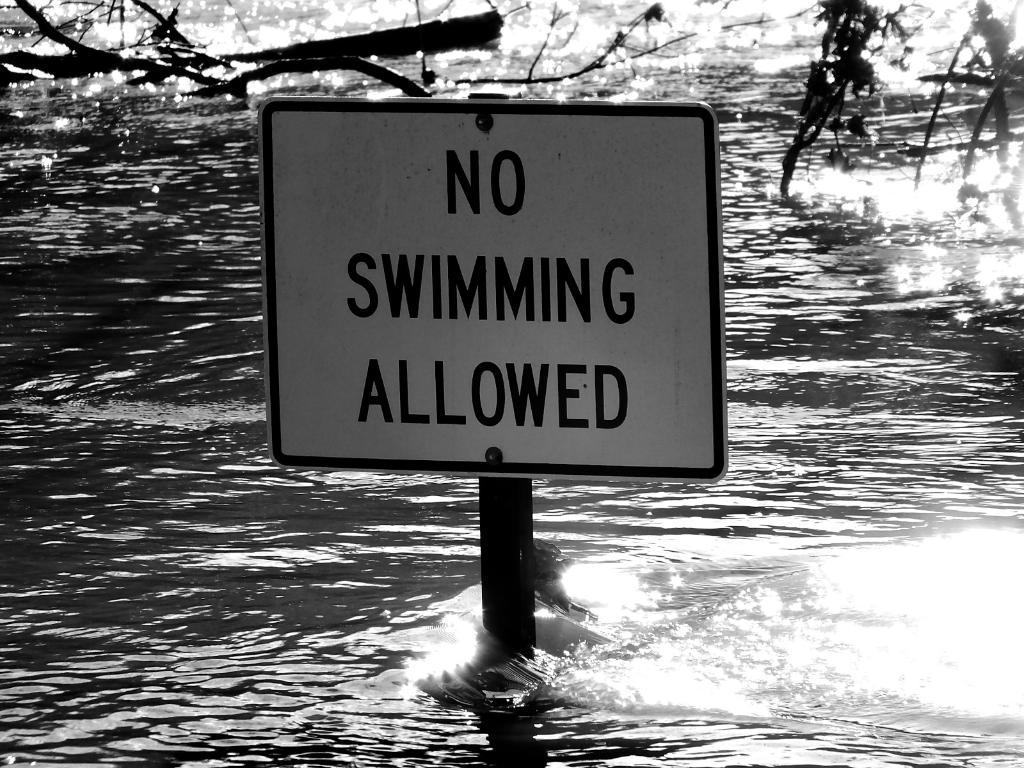What is the main object in the middle of the image? There is a board in the middle of the image. What can be seen in the distance behind the board? Trees are visible in the background of the image. What natural feature is present at the bottom of the image? There is a body of water (a lake) at the bottom of the image. How many chairs are placed on the shelf in the image? There are no chairs or shelves present in the image. 